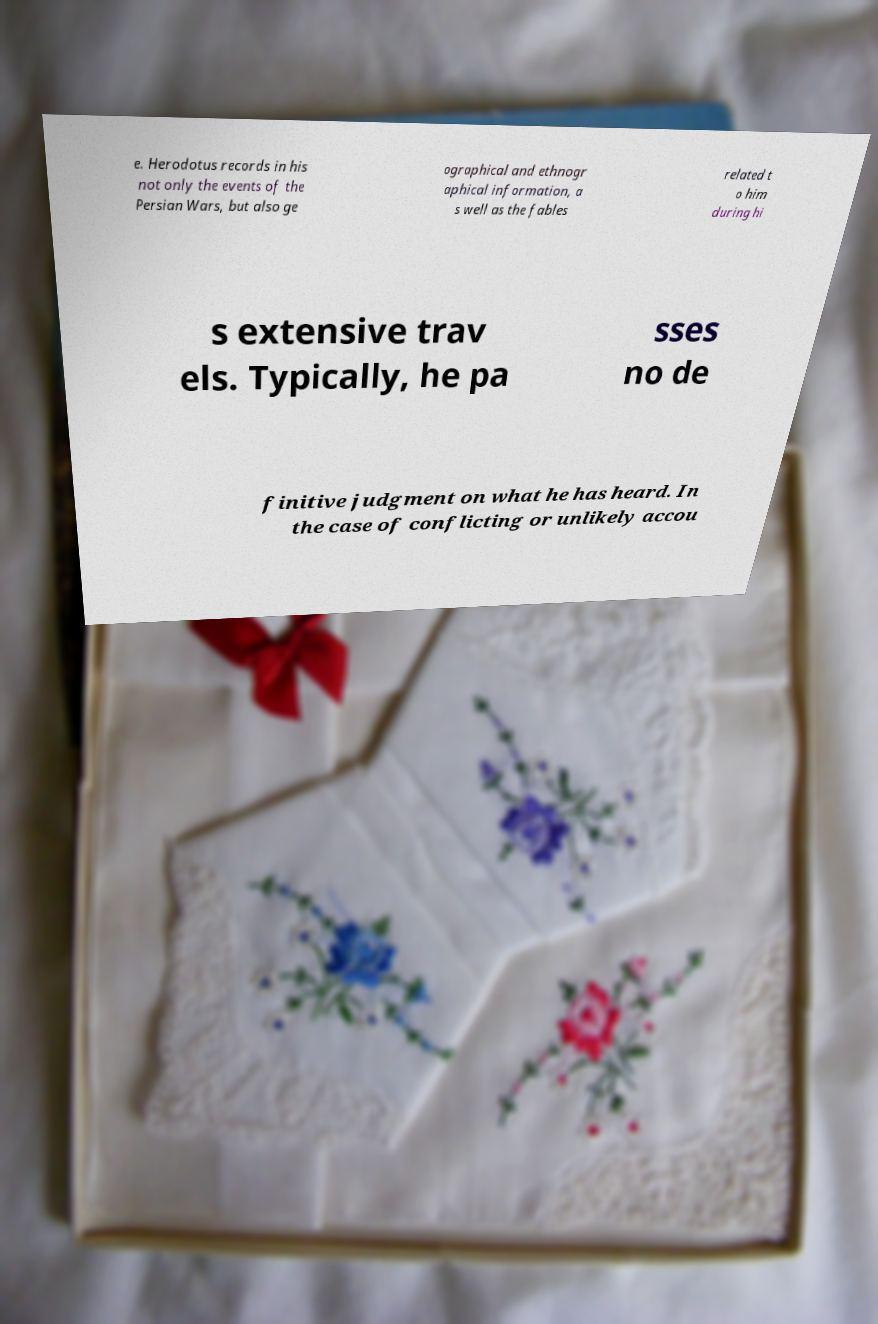Please identify and transcribe the text found in this image. e. Herodotus records in his not only the events of the Persian Wars, but also ge ographical and ethnogr aphical information, a s well as the fables related t o him during hi s extensive trav els. Typically, he pa sses no de finitive judgment on what he has heard. In the case of conflicting or unlikely accou 